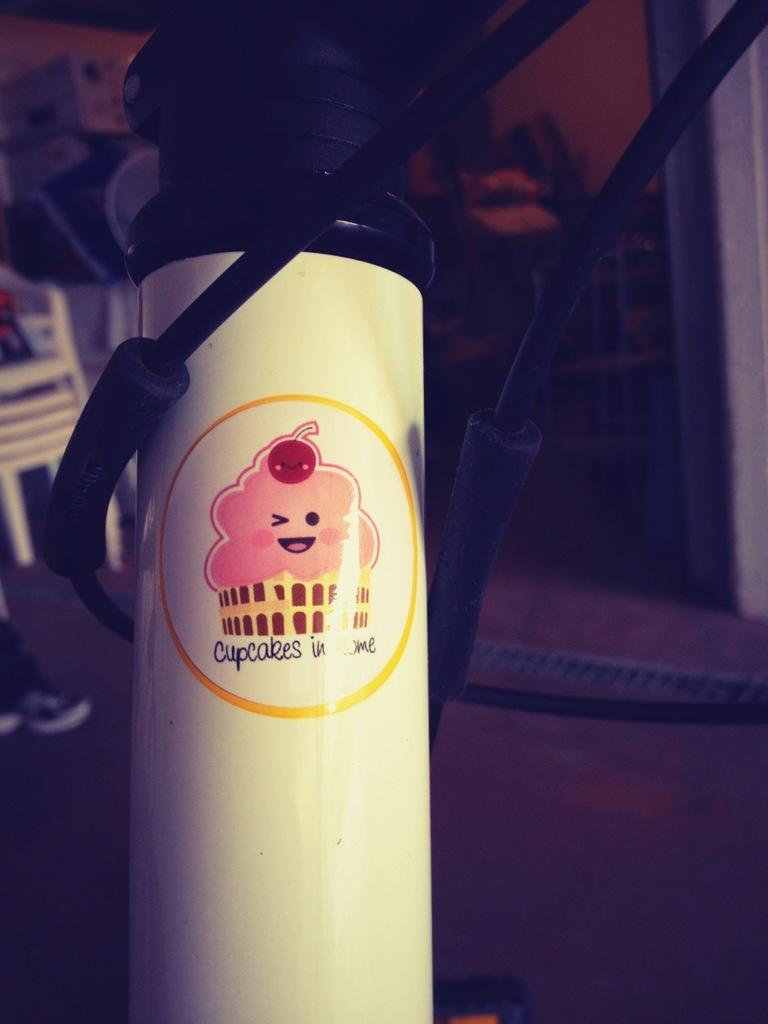Provide a one-sentence caption for the provided image. A white container has a picture of a cupcake and the word cupcake below it. 